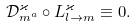<formula> <loc_0><loc_0><loc_500><loc_500>\mathcal { D } _ { m ^ { a } } ^ { \varkappa } \circ L _ { l \to m } ^ { \varkappa } \equiv 0 .</formula> 